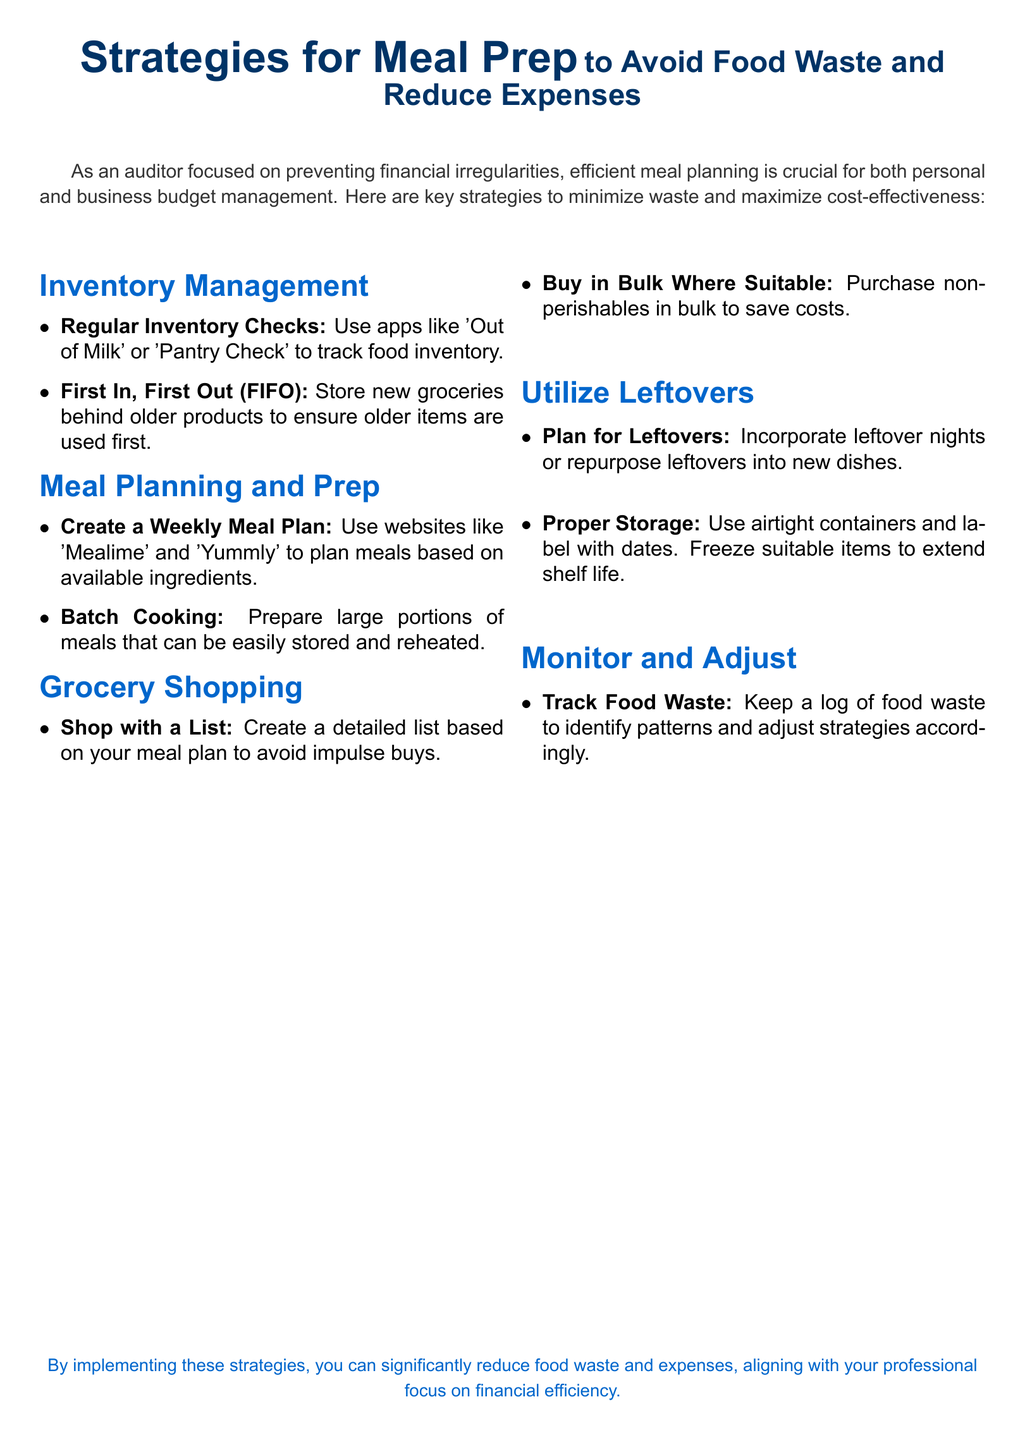What is the main focus of the meal prep strategies? The main focus is on avoiding food waste and reducing expenses.
Answer: Avoiding food waste and reducing expenses What are two apps mentioned for inventory management? The document lists 'Out of Milk' and 'Pantry Check' as apps for tracking food inventory.
Answer: Out of Milk, Pantry Check What does FIFO stand for? FIFO stands for First In, First Out, a method of organizing inventory.
Answer: First In, First Out Which websites can be used for meal planning? 'Mealime' and 'Yummly' are suggested for creating a weekly meal plan based on available ingredients.
Answer: Mealime, Yummly What is one method suggested for utilizing leftovers? The document mentions incorporating leftover nights or repurposing leftovers into new dishes.
Answer: Repurpose leftovers What should you use to track food waste? Keeping a log of food waste is recommended to identify patterns.
Answer: Log of food waste What is one strategy for grocery shopping mentioned? Shopping with a list is emphasized to avoid impulse buys.
Answer: Shop with a list What storage method is advised for leftovers? The document suggests using airtight containers and labeling with dates for proper storage.
Answer: Airtight containers, label with dates 